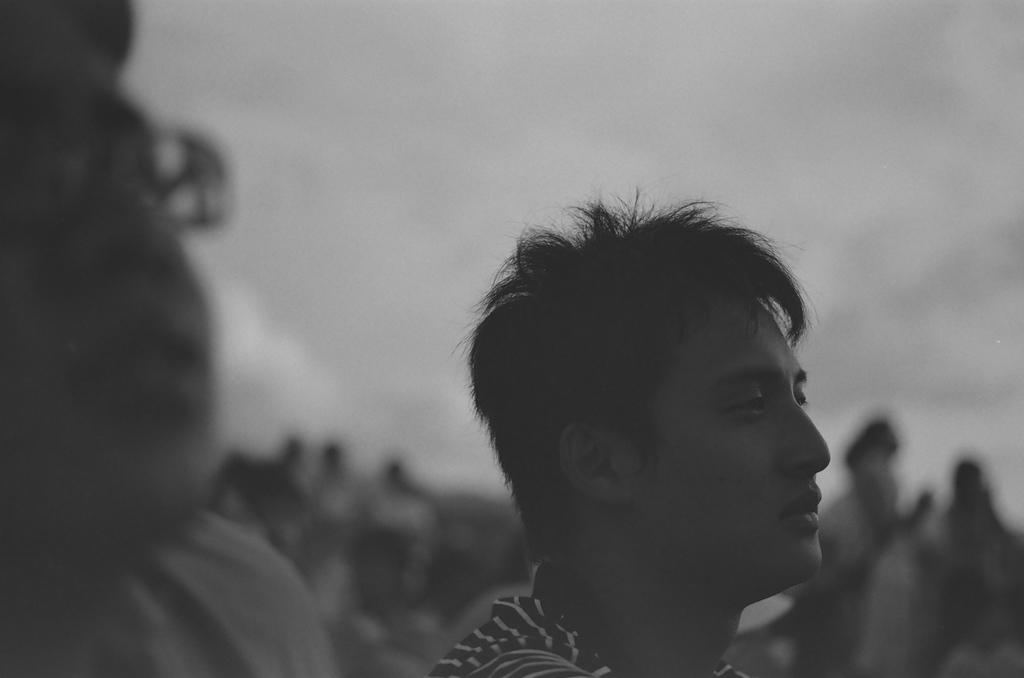How many people are visible in the image? There are two persons in the image. Can you describe the setting of the image? The image is in black and white. Are there any other people visible in the image besides the two main subjects? Yes, there are other persons standing in the background of the image. Reasoning: Let's think step by step by step in order to produce the conversation. We start by identifying the number of people in the image, which is two. Then, we describe the color scheme of the image, which is black and white. Finally, we acknowledge the presence of additional people in the background, providing a more complete picture of the scene. Absurd Question/Answer: What type of tax is being discussed by the two persons in the image? There is no indication in the image that the two persons are discussing any type of tax. What is the main subject of the image? The main subject of the image is a car. Where is the car located in the image? The car is parked on the street. What can be seen in the background of the image? There are trees in the background of the image. What is visible at the top of the image? The sky is visible in the image. Reasoning: Let's think step by step in order to produce the conversation. We start by identifying the main subject of the image, which is the car. Then, we describe the location of the car, noting that it is parked on the street. Next, we observe the background of the image, which includes trees. Finally, we describe the sky's condition, which is visible in the image. Absurd Question/Answer: Can you tell me how many dancers are performing near the car in the image? There are no dancers present in the image; it features a car parked on the street with trees and the sky visible in the background. 